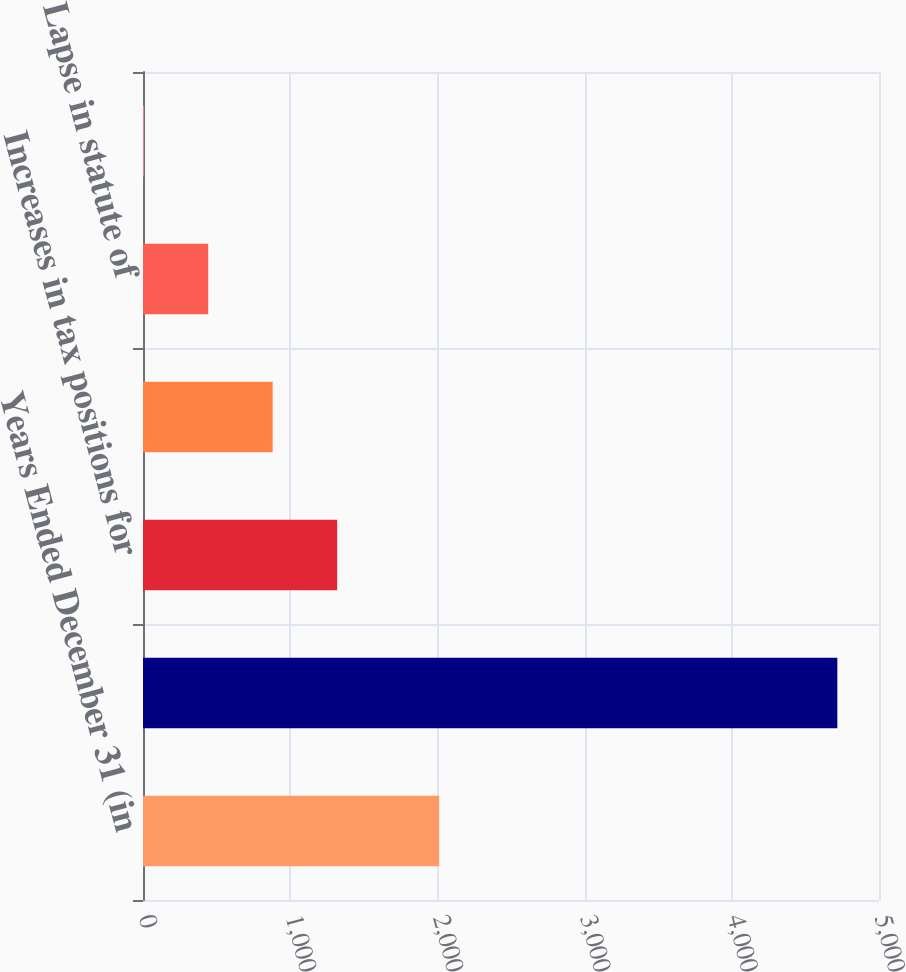Convert chart. <chart><loc_0><loc_0><loc_500><loc_500><bar_chart><fcel>Years Ended December 31 (in<fcel>Gross unrecognized tax<fcel>Increases in tax positions for<fcel>Decreases in tax positions for<fcel>Lapse in statute of<fcel>Settlements<nl><fcel>2012<fcel>4717<fcel>1319<fcel>881<fcel>443<fcel>5<nl></chart> 